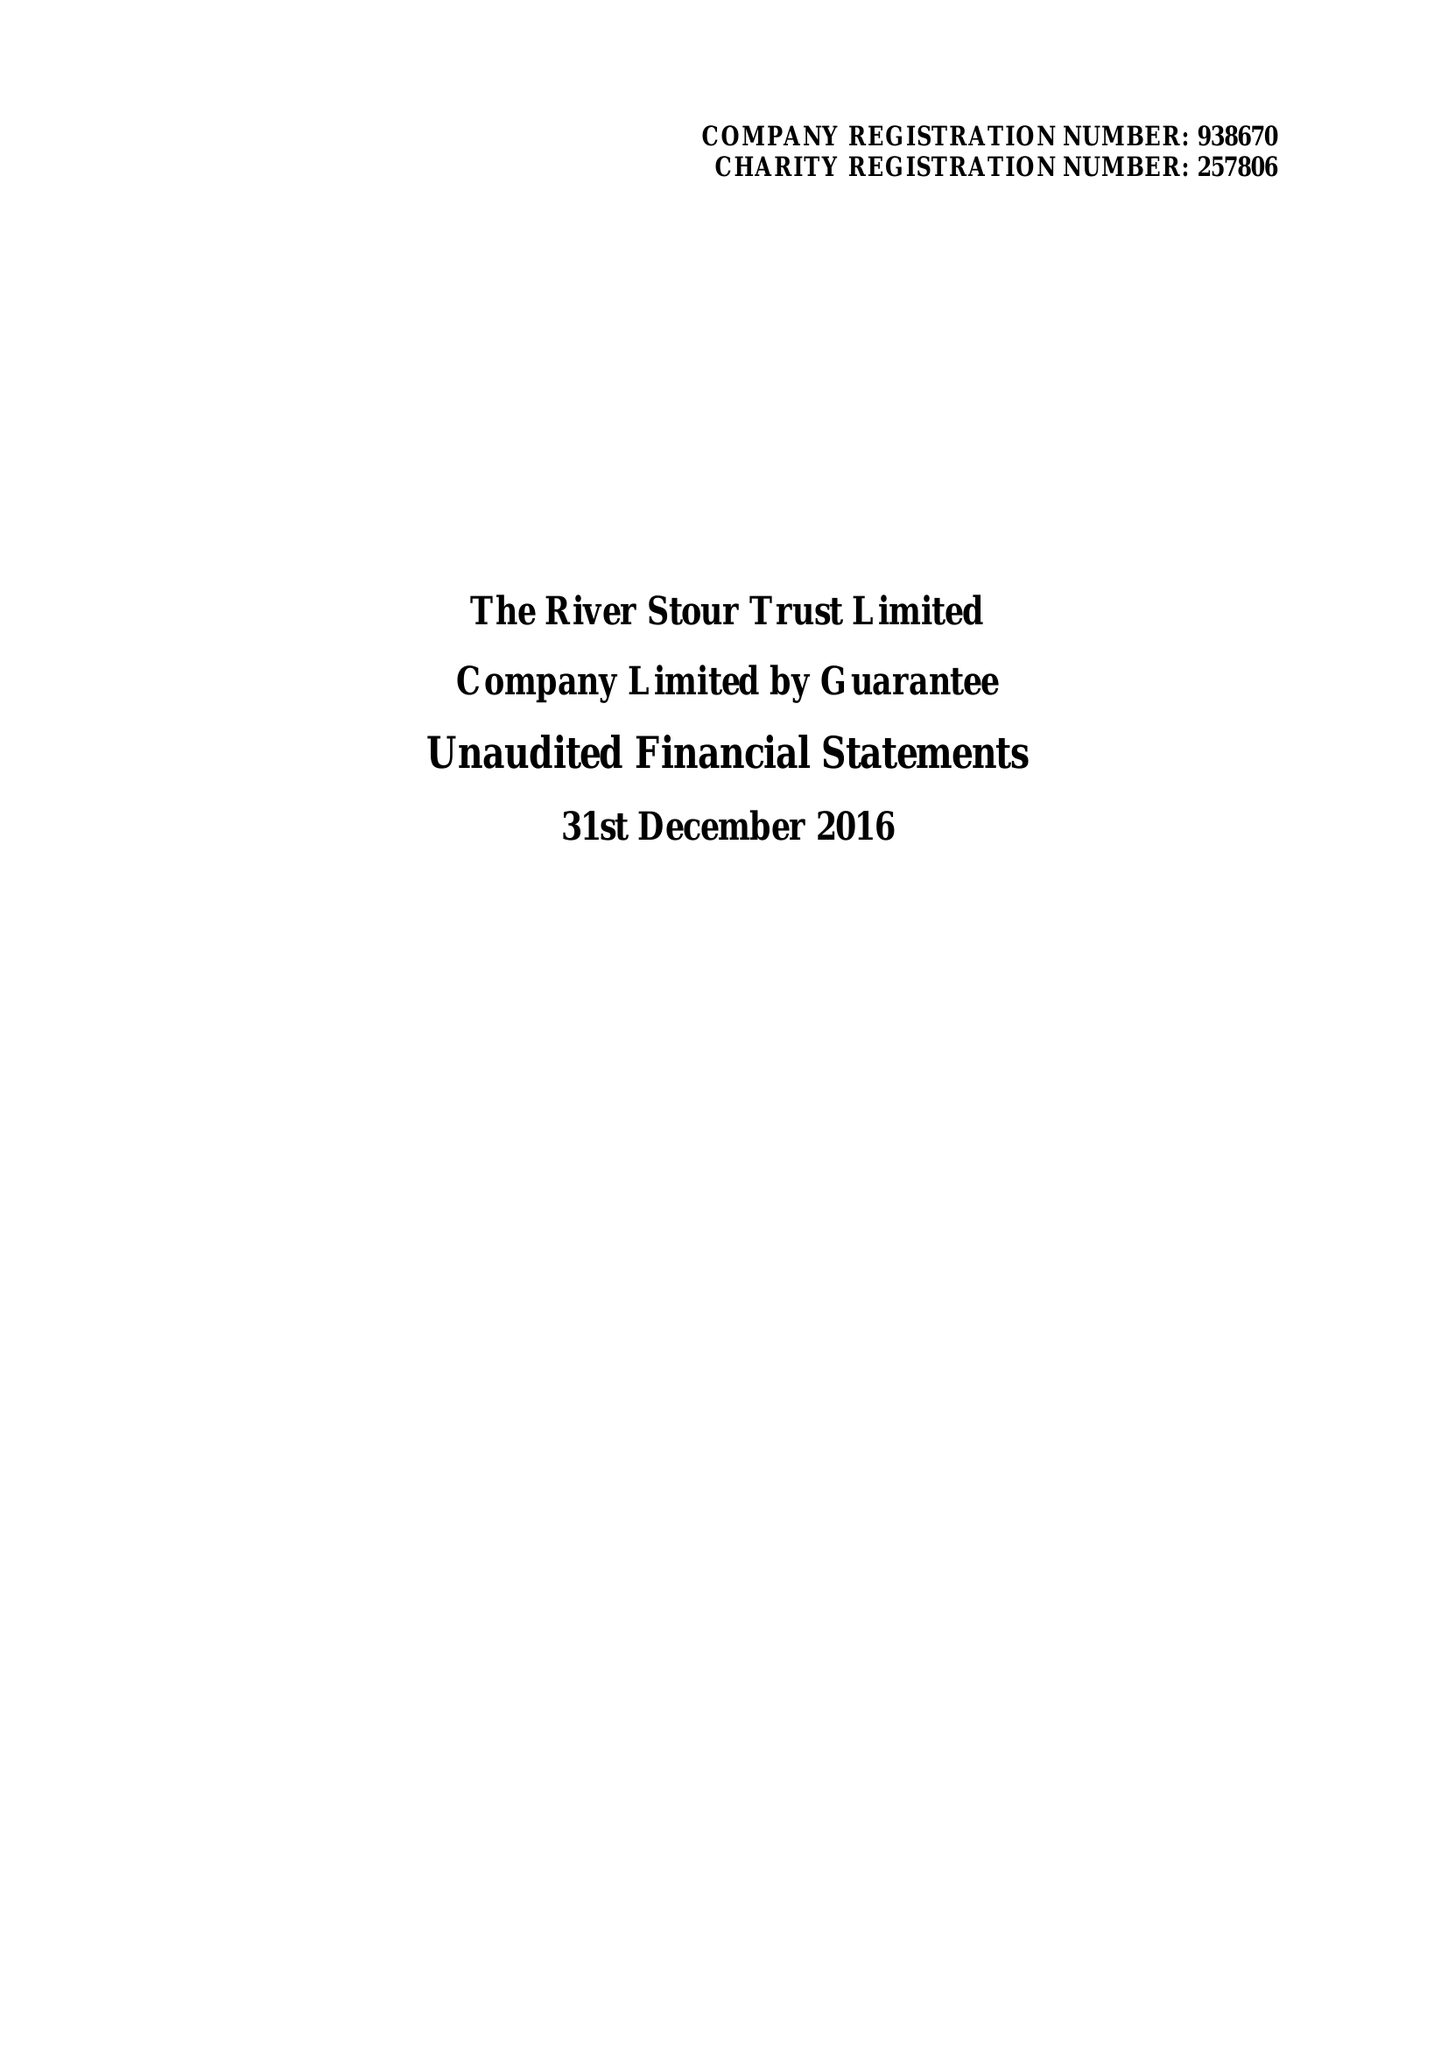What is the value for the address__postcode?
Answer the question using a single word or phrase. CO10 2AN 